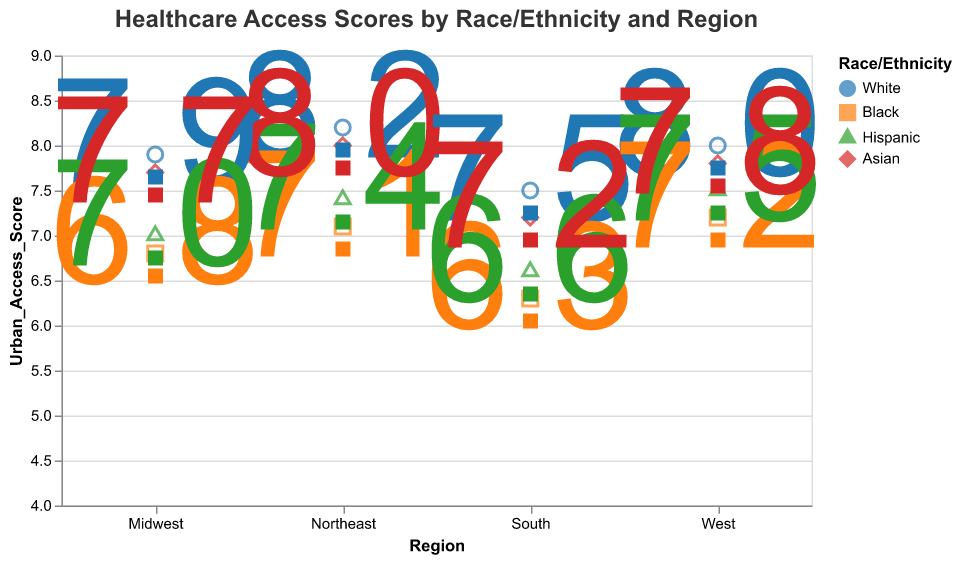Which region has the highest Urban Access Score for White people? The figure shows that the Northeast region has the highest Urban Access Score for White people, 8.2
Answer: Northeast What is the difference in Urban Access Scores between Black and Hispanic people in the Midwest? According to the figure, the Urban Access Score for Black people in the Midwest is 6.8 and for Hispanic people is 7.0. The difference is 7.0 - 6.8 = 0.2
Answer: 0.2 Which racial/ethnic group has the lowest Rural Access Score in the South? The figure shows that in the South, Black people have the lowest Rural Access Score of 4.5
Answer: Black What is the average Urban Access Score for Asians across all regions? Adding up the Urban Access Scores for Asians in each region: 8.0 (Northeast) + 7.7 (Midwest) + 7.2 (South) + 7.8 (West) = 30.7. There are 4 regions, so the average is 30.7 / 4 = 7.675
Answer: 7.7 How does the Rural Access Score for Hispanic people in the Northeast compare to the Rural Access Score for Hispanic people in the Midwest? The figure shows the Rural Access Score for Hispanic people in the Northeast is 5.6 and in the Midwest is 5.2. The score is higher in the Northeast.
Answer: Northeast has higher Which region has the smallest gap between Urban and Rural Access Scores for Black people? The gap is calculated as Urban_Access_Score - Rural_Access_Score for each region. For the Northeast, it's 7.1 - 5.3 = 1.8. For the Midwest, it's 6.8 - 4.9 = 1.9. For the South, it's 6.3 - 4.5 = 1.8. For the West, it's 7.2 - 5.5 = 1.7. So the West has the smallest gap.
Answer: West In the West, which racial/ethnic group has the highest Urban Access Score? According to the figure, in the West, White people have the highest Urban Access Score of 8.0
Answer: White What is the sum of Rural Access Scores for all races/ethnicities in the Midwest? Summing up the Rural Access Scores in the Midwest: 6.2 (White) + 4.9 (Black) + 5.2 (Hispanic) + 5.8 (Asian) = 22.1
Answer: 22.1 Which racial/ethnic group in the Northeast has a higher Urban Access Score than the Urban Access Score for White people in the South? In the figure, the Urban Access Score for White people in the South is 7.5. In the Northeast, both White people (8.2) and Asian people (8.0) have higher Urban Access Scores. Thus, the groups are White and Asian.
Answer: White, Asian 